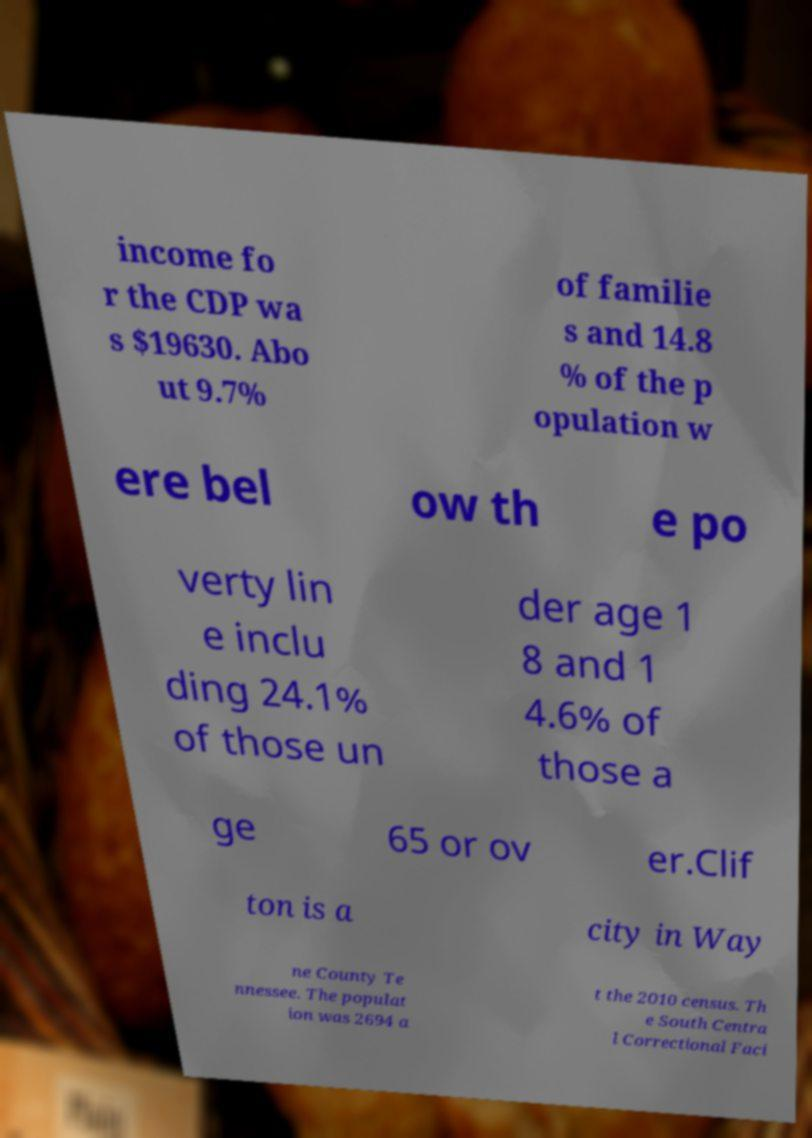What messages or text are displayed in this image? I need them in a readable, typed format. income fo r the CDP wa s $19630. Abo ut 9.7% of familie s and 14.8 % of the p opulation w ere bel ow th e po verty lin e inclu ding 24.1% of those un der age 1 8 and 1 4.6% of those a ge 65 or ov er.Clif ton is a city in Way ne County Te nnessee. The populat ion was 2694 a t the 2010 census. Th e South Centra l Correctional Faci 